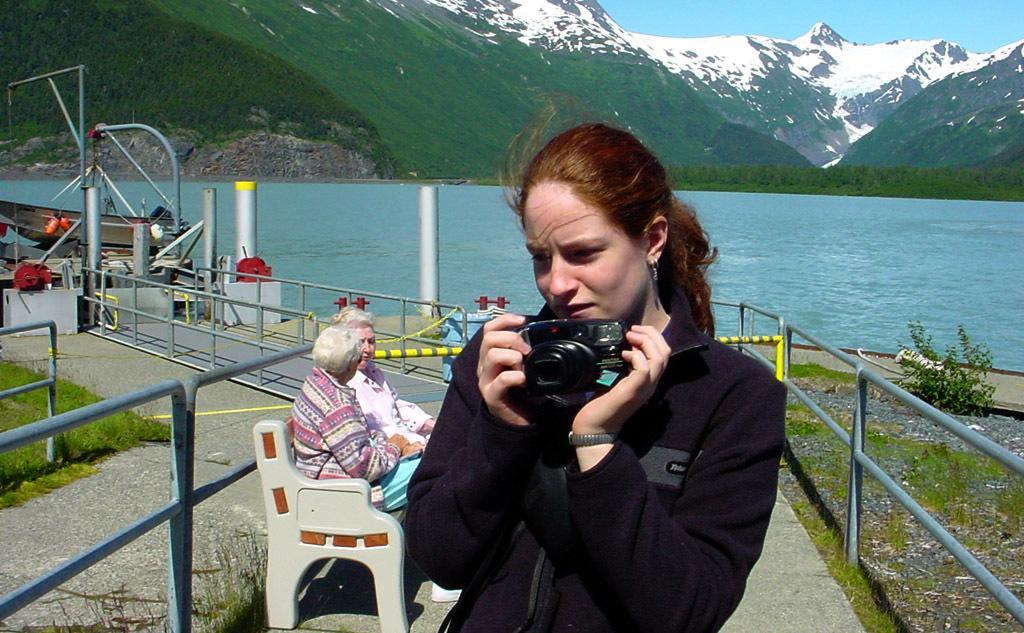Can you describe this image briefly? In the middle of this image, there is a woman in a jacket, holding a camera and watching something. On the left side, there are two persons sitting on a bench. Beside them, there is a fence. On the right side, there are a road, a plant and grass on the ground. In the background, there are poles, there is water, there are mountains on which there is snow, blue sky and there are other objects. 